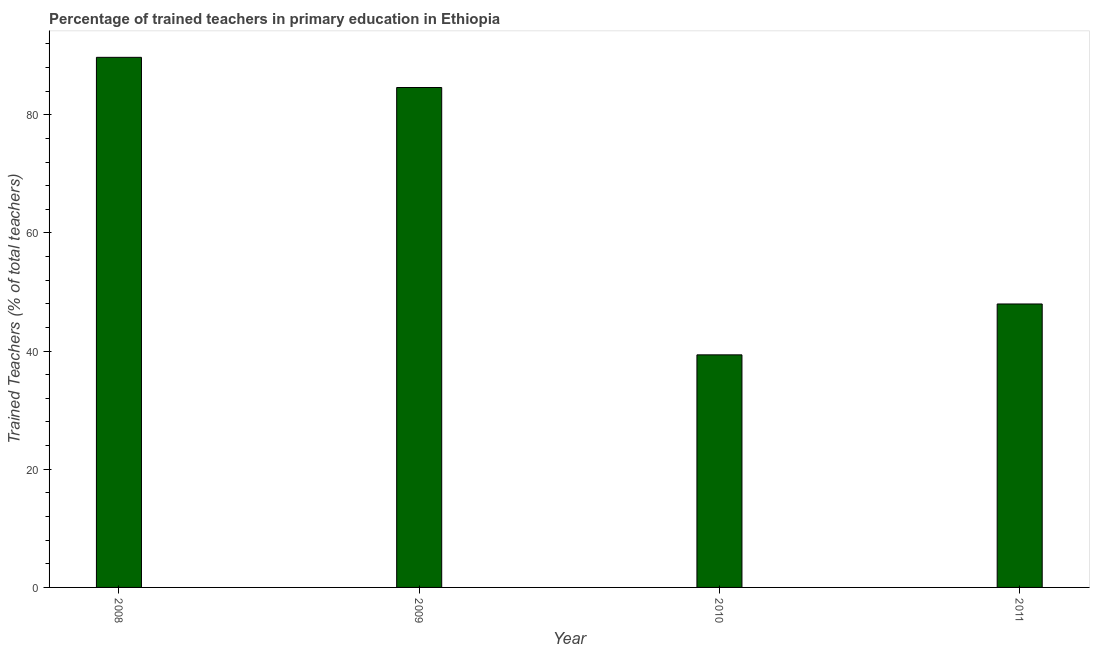Does the graph contain grids?
Ensure brevity in your answer.  No. What is the title of the graph?
Provide a succinct answer. Percentage of trained teachers in primary education in Ethiopia. What is the label or title of the X-axis?
Give a very brief answer. Year. What is the label or title of the Y-axis?
Give a very brief answer. Trained Teachers (% of total teachers). What is the percentage of trained teachers in 2010?
Make the answer very short. 39.36. Across all years, what is the maximum percentage of trained teachers?
Keep it short and to the point. 89.72. Across all years, what is the minimum percentage of trained teachers?
Offer a terse response. 39.36. In which year was the percentage of trained teachers maximum?
Provide a short and direct response. 2008. In which year was the percentage of trained teachers minimum?
Your answer should be compact. 2010. What is the sum of the percentage of trained teachers?
Your answer should be very brief. 261.66. What is the difference between the percentage of trained teachers in 2009 and 2010?
Your answer should be very brief. 45.25. What is the average percentage of trained teachers per year?
Your answer should be compact. 65.42. What is the median percentage of trained teachers?
Provide a short and direct response. 66.29. In how many years, is the percentage of trained teachers greater than 28 %?
Provide a succinct answer. 4. Do a majority of the years between 2008 and 2009 (inclusive) have percentage of trained teachers greater than 4 %?
Ensure brevity in your answer.  Yes. What is the ratio of the percentage of trained teachers in 2009 to that in 2011?
Offer a very short reply. 1.76. Is the percentage of trained teachers in 2010 less than that in 2011?
Keep it short and to the point. Yes. What is the difference between the highest and the second highest percentage of trained teachers?
Provide a short and direct response. 5.11. Is the sum of the percentage of trained teachers in 2008 and 2009 greater than the maximum percentage of trained teachers across all years?
Your answer should be very brief. Yes. What is the difference between the highest and the lowest percentage of trained teachers?
Ensure brevity in your answer.  50.35. Are all the bars in the graph horizontal?
Make the answer very short. No. How many years are there in the graph?
Offer a terse response. 4. Are the values on the major ticks of Y-axis written in scientific E-notation?
Your answer should be compact. No. What is the Trained Teachers (% of total teachers) of 2008?
Provide a short and direct response. 89.72. What is the Trained Teachers (% of total teachers) in 2009?
Offer a very short reply. 84.61. What is the Trained Teachers (% of total teachers) of 2010?
Ensure brevity in your answer.  39.36. What is the Trained Teachers (% of total teachers) of 2011?
Give a very brief answer. 47.97. What is the difference between the Trained Teachers (% of total teachers) in 2008 and 2009?
Keep it short and to the point. 5.11. What is the difference between the Trained Teachers (% of total teachers) in 2008 and 2010?
Offer a terse response. 50.35. What is the difference between the Trained Teachers (% of total teachers) in 2008 and 2011?
Offer a very short reply. 41.74. What is the difference between the Trained Teachers (% of total teachers) in 2009 and 2010?
Make the answer very short. 45.25. What is the difference between the Trained Teachers (% of total teachers) in 2009 and 2011?
Ensure brevity in your answer.  36.64. What is the difference between the Trained Teachers (% of total teachers) in 2010 and 2011?
Offer a very short reply. -8.61. What is the ratio of the Trained Teachers (% of total teachers) in 2008 to that in 2009?
Provide a short and direct response. 1.06. What is the ratio of the Trained Teachers (% of total teachers) in 2008 to that in 2010?
Your response must be concise. 2.28. What is the ratio of the Trained Teachers (% of total teachers) in 2008 to that in 2011?
Give a very brief answer. 1.87. What is the ratio of the Trained Teachers (% of total teachers) in 2009 to that in 2010?
Offer a very short reply. 2.15. What is the ratio of the Trained Teachers (% of total teachers) in 2009 to that in 2011?
Give a very brief answer. 1.76. What is the ratio of the Trained Teachers (% of total teachers) in 2010 to that in 2011?
Your response must be concise. 0.82. 